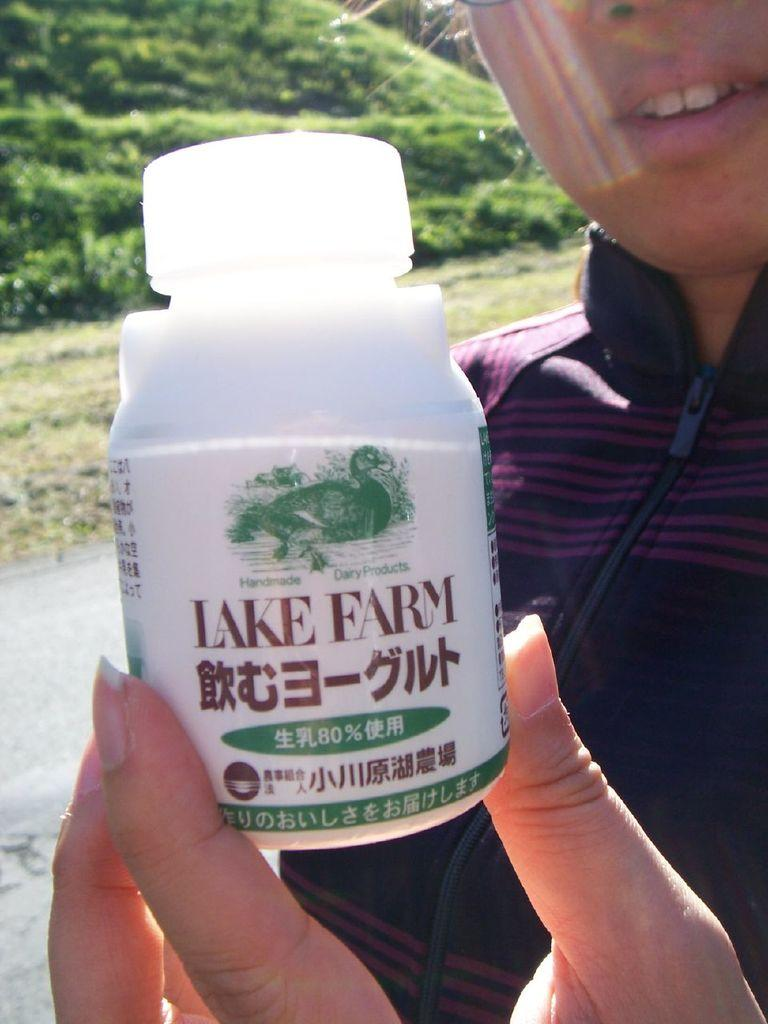What is present in the image? There is a person in the image. What is the person holding? The person is holding a bottle. What type of maid is visible in the image? There is no maid present in the image; it only features a person holding a bottle. 